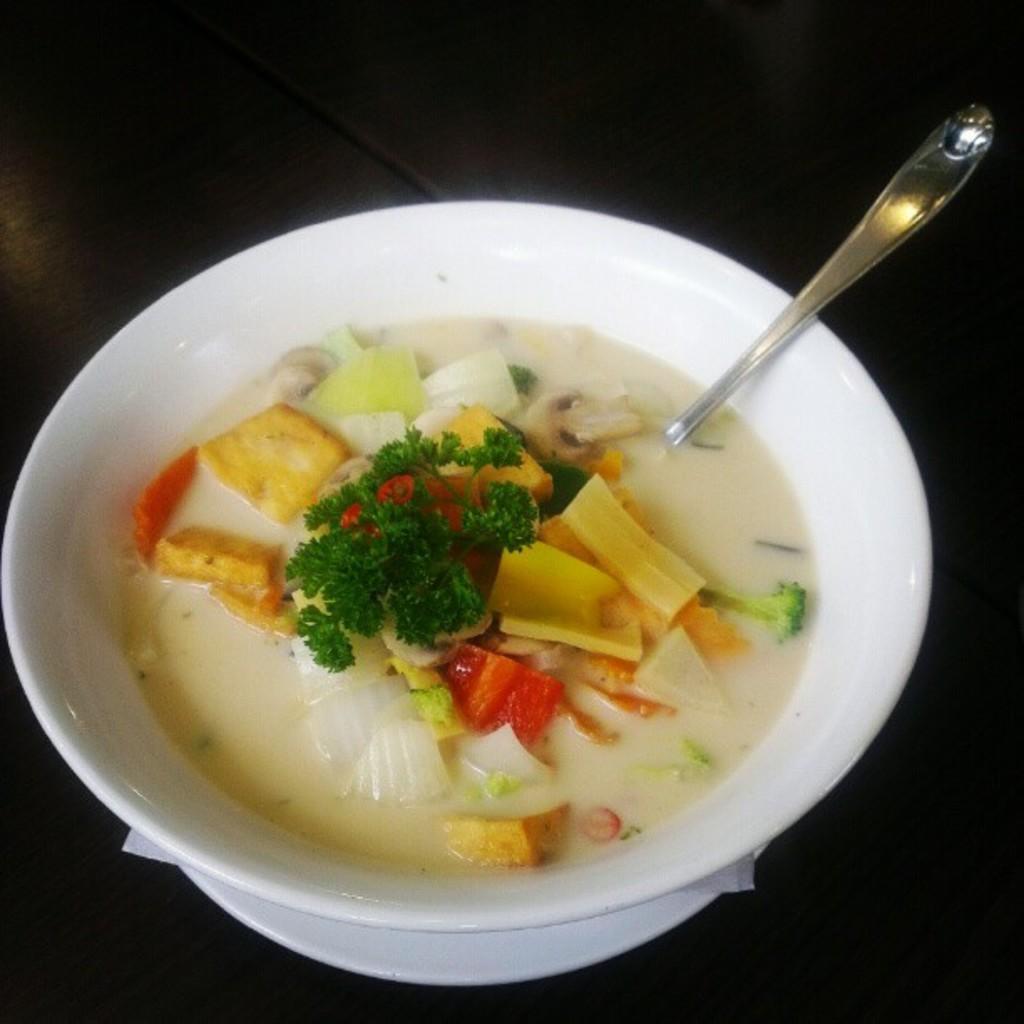Describe this image in one or two sentences. There is a bowl on a black surface. In the bowl there is a food item and a spoon. 